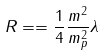<formula> <loc_0><loc_0><loc_500><loc_500>R = = \frac { 1 } { 4 } \frac { m ^ { 2 } } { m ^ { 2 } _ { p } } \lambda</formula> 